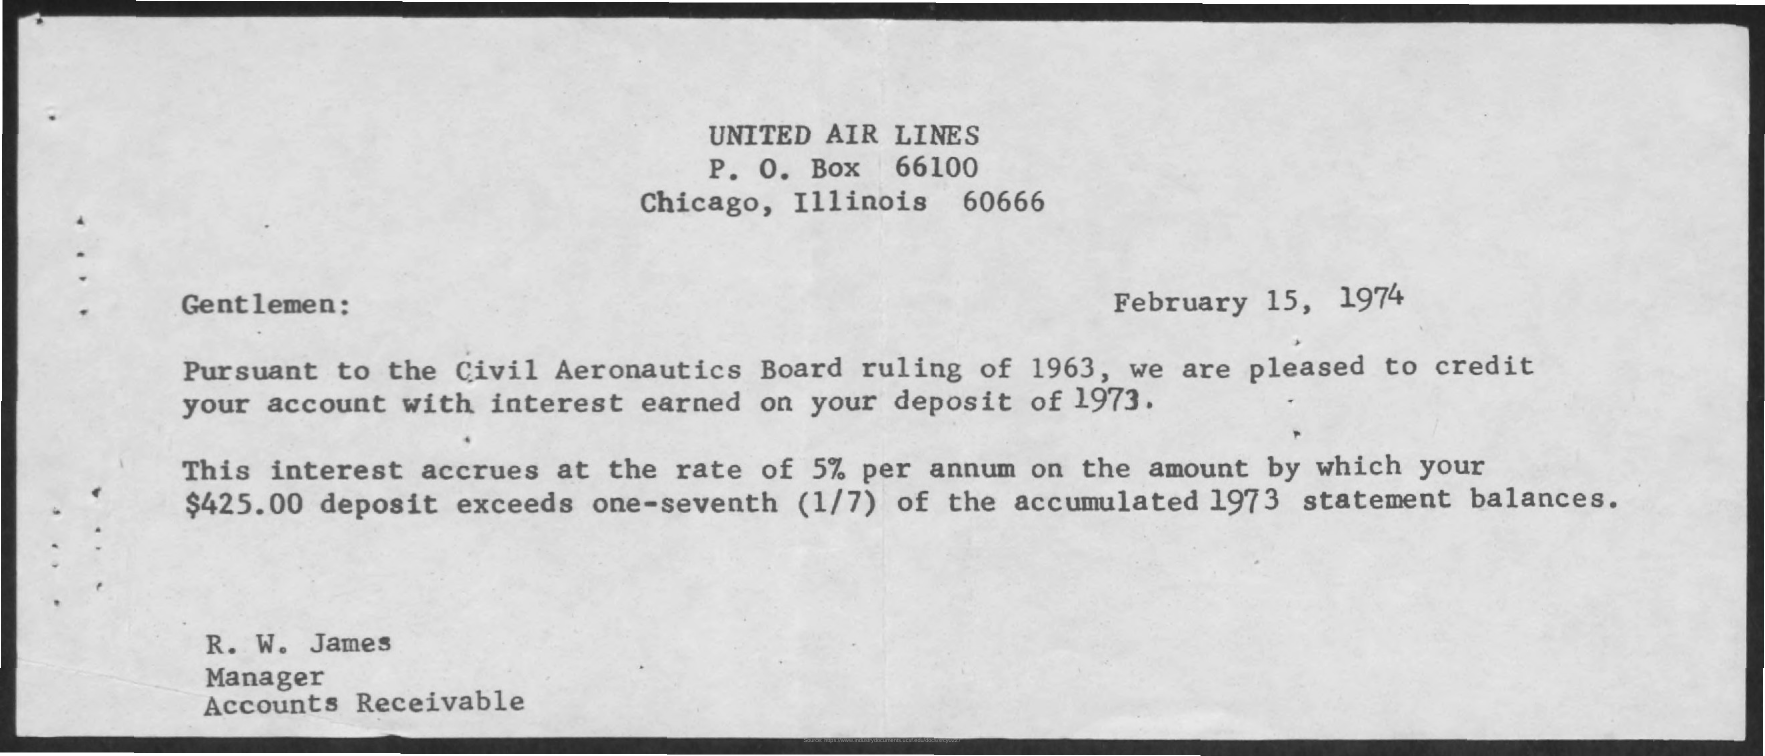Specify some key components in this picture. The date mentioned in this document is February 15, 1974. The sender of this document is R. W. James. The P.O.Box number given is 66100. 